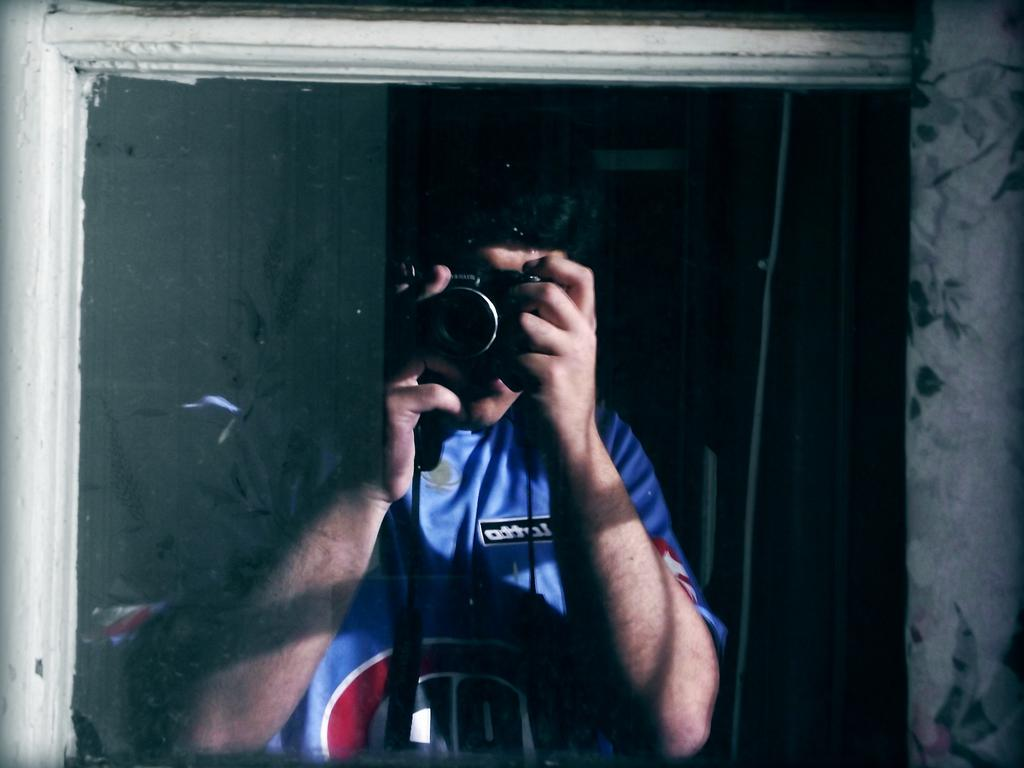What is the main subject of the image? There is a person in the image. What is the person doing in the image? The person is holding a camera and taking a photograph. What can be observed about the background of the image? The background of the image is dark. How many bridges can be seen in the image? There are no bridges present in the image. What type of control does the person have over the camera in the image? The image does not provide information about the type of control the person has over the camera. 